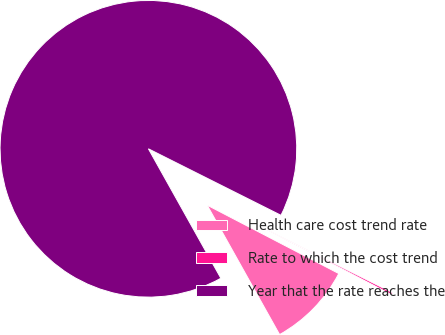Convert chart. <chart><loc_0><loc_0><loc_500><loc_500><pie_chart><fcel>Health care cost trend rate<fcel>Rate to which the cost trend<fcel>Year that the rate reaches the<nl><fcel>9.25%<fcel>0.23%<fcel>90.52%<nl></chart> 